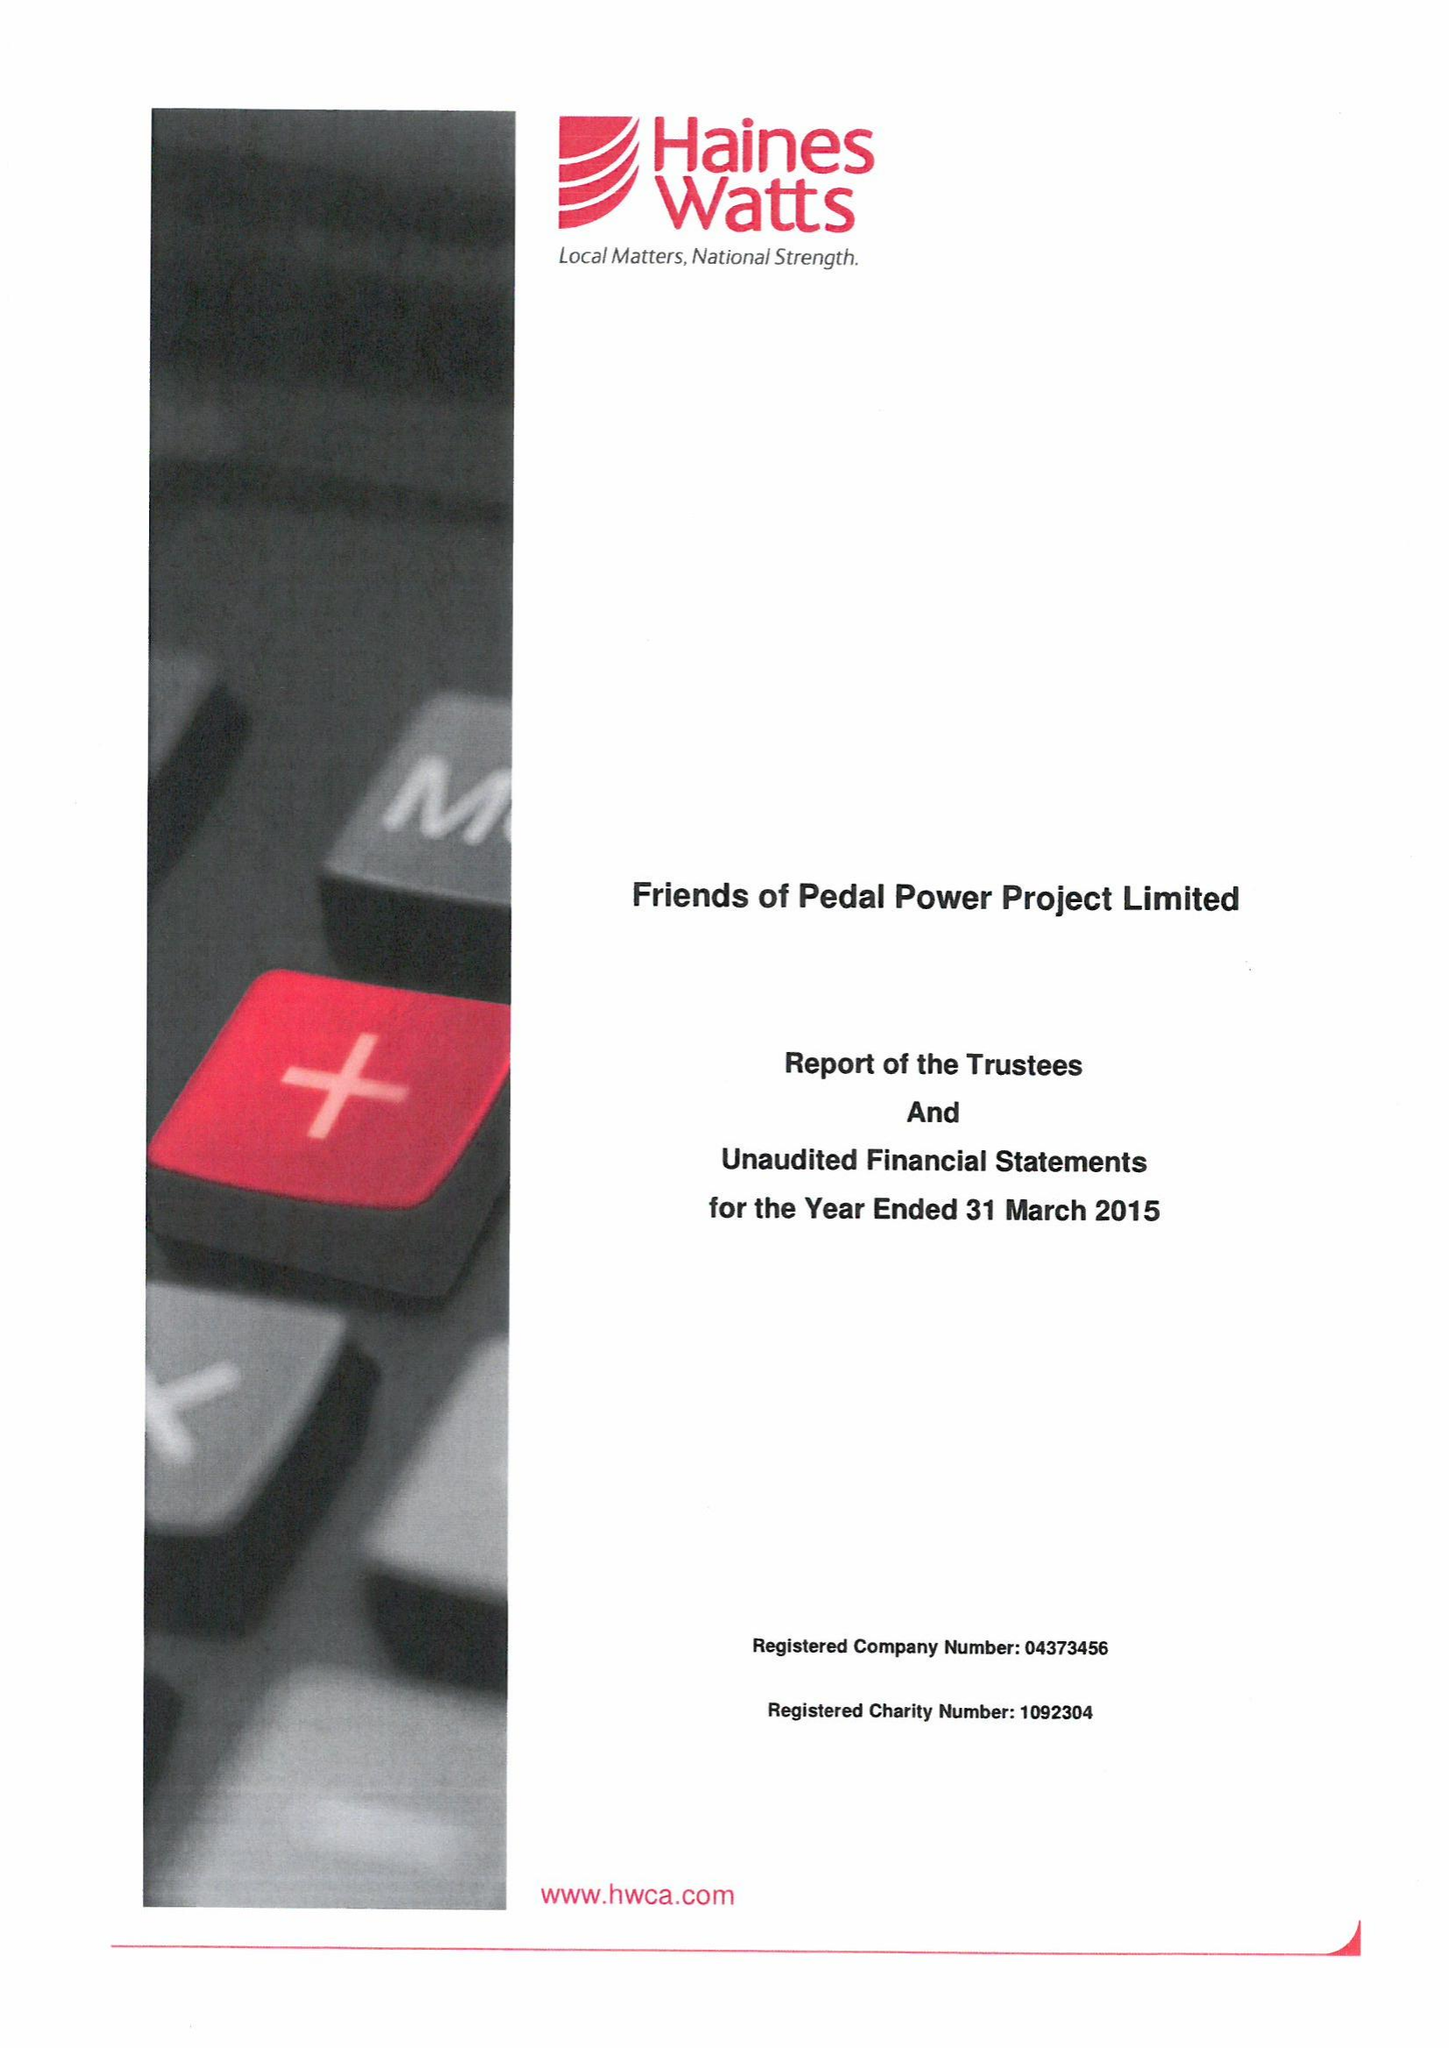What is the value for the address__street_line?
Answer the question using a single word or phrase. 105 PEARL STREET 